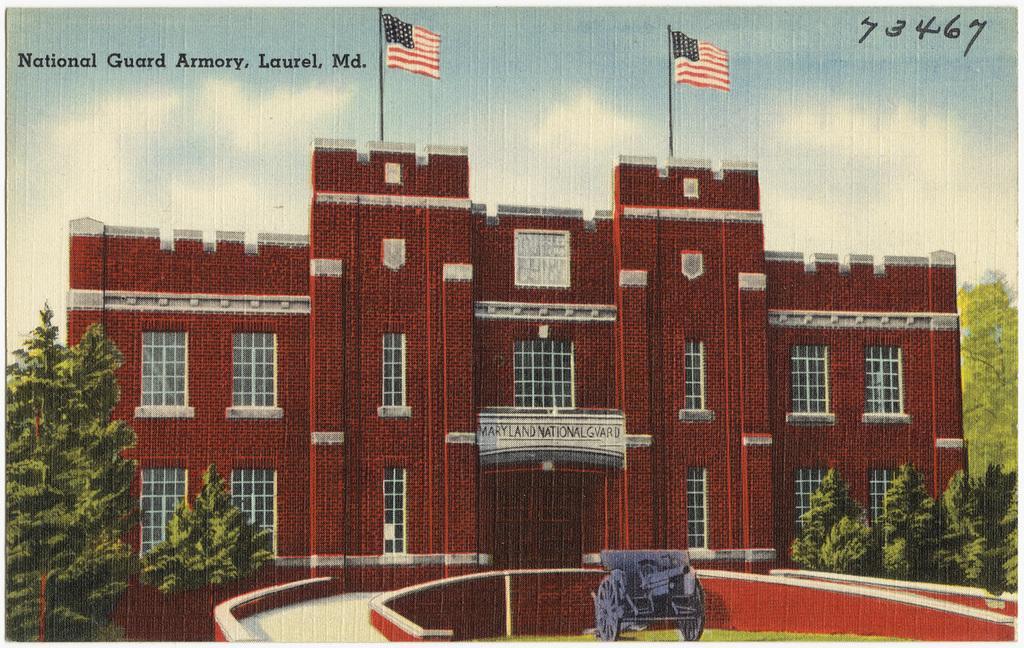How would you summarize this image in a sentence or two? It is a poster. In this image, we can see a building with glass windows, walls. At the bottom, we can see a walkway, weapon, grass, plants and trees. Background there is a sky, flags with poles. Here we can see some text and numerical numbers. 